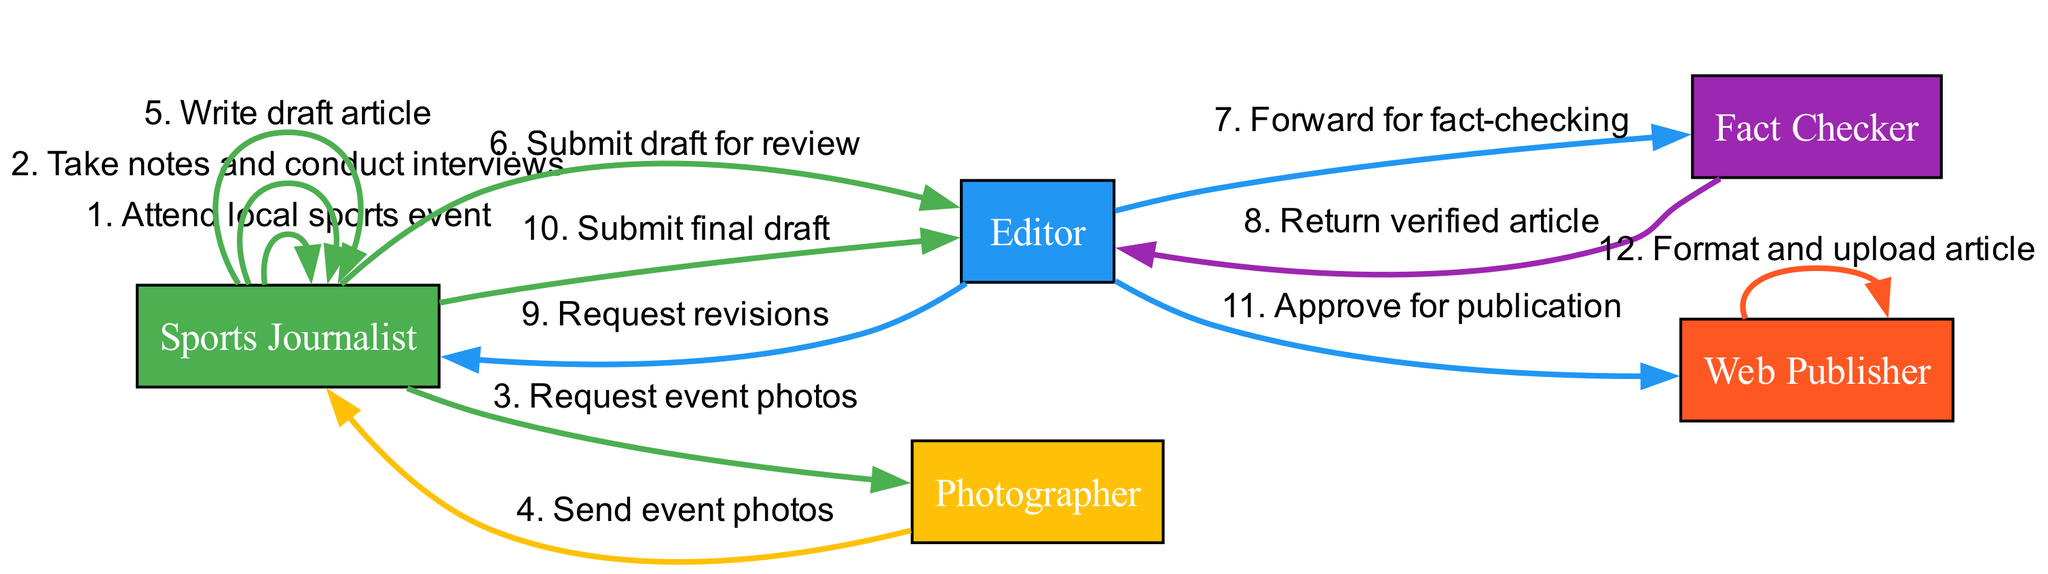What is the first action taken by the Sports Journalist? The diagram shows that the first action in the sequence is "Attend local sports event" performed by the Sports Journalist.
Answer: Attend local sports event How many actors are involved in the process? By counting the unique actors listed in the diagram, we can see that there are five actors: Sports Journalist, Editor, Photographer, Fact Checker, and Web Publisher.
Answer: Five Which actor requests the event photos? The diagram indicates that the Sports Journalist requests the event photos from the Photographer.
Answer: Sports Journalist What is the action taken by the Web Publisher? The final action taken is "Format and upload article," which is performed by the Web Publisher.
Answer: Format and upload article What action occurs immediately after submitting the draft for review? After the Sports Journalist submits the draft for review, the Editor forwards it for fact-checking as the next action.
Answer: Forward for fact-checking How many total actions are involved in the sequence? By counting each action listed in the sequence, we find that there are twelve actions carried out within the diagram.
Answer: Twelve What document is returned by the Fact Checker? The Fact Checker returns the "verified article" to the Editor as indicated in the sequence of actions.
Answer: Verified article Which actor receives the final draft? The final draft is submitted by the Sports Journalist to the Editor, who is the recipient of this action.
Answer: Editor What is the relationship between the Editor and the Web Publisher? The Editor approves the article for publication and subsequently hands it off to the Web Publisher to format and upload.
Answer: Approve for publication 